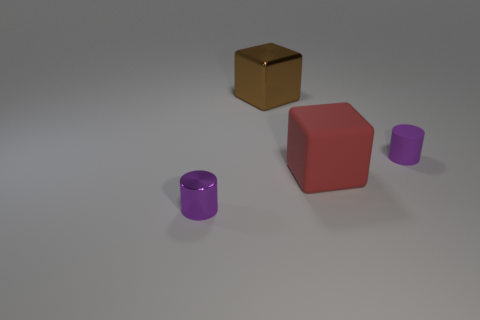What material is the tiny object that is the same color as the tiny matte cylinder?
Your answer should be compact. Metal. How big is the object that is both behind the big red object and left of the red rubber object?
Ensure brevity in your answer.  Large. The metallic thing that is behind the small purple cylinder that is to the left of the purple rubber object is what color?
Keep it short and to the point. Brown. How many yellow objects are either balls or small matte objects?
Provide a short and direct response. 0. The object that is both left of the red cube and right of the purple metallic cylinder is what color?
Provide a succinct answer. Brown. How many big objects are either cyan cylinders or brown metallic objects?
Make the answer very short. 1. What size is the brown shiny thing that is the same shape as the red matte thing?
Provide a succinct answer. Large. There is a big red thing; what shape is it?
Keep it short and to the point. Cube. Are the brown block and the purple cylinder that is on the left side of the small rubber cylinder made of the same material?
Ensure brevity in your answer.  Yes. What number of shiny objects are either red objects or tiny purple cylinders?
Ensure brevity in your answer.  1. 